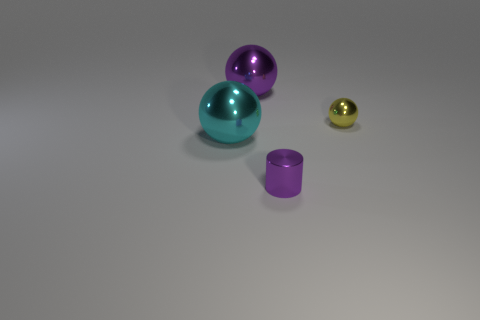The small object that is the same material as the cylinder is what color?
Offer a terse response. Yellow. Does the purple object in front of the yellow ball have the same size as the large purple thing?
Offer a very short reply. No. The other large metal object that is the same shape as the cyan metallic object is what color?
Offer a terse response. Purple. There is a tiny metal thing behind the shiny ball on the left side of the purple metal thing behind the tiny ball; what shape is it?
Your answer should be compact. Sphere. Is the shape of the cyan metallic object the same as the large purple object?
Offer a terse response. Yes. There is a big thing behind the big metallic sphere in front of the large purple object; what is its shape?
Ensure brevity in your answer.  Sphere. Is there a large yellow matte cube?
Provide a short and direct response. No. There is a metal sphere that is right of the purple object right of the large purple metal object; what number of small yellow metal spheres are behind it?
Your answer should be compact. 0. Do the tiny purple metal object and the thing on the right side of the tiny metallic cylinder have the same shape?
Provide a succinct answer. No. Is the number of yellow things greater than the number of big red rubber blocks?
Make the answer very short. Yes. 